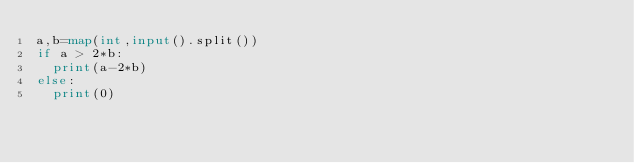<code> <loc_0><loc_0><loc_500><loc_500><_Python_>a,b=map(int,input().split())
if a > 2*b:
  print(a-2*b)
else:
  print(0)</code> 